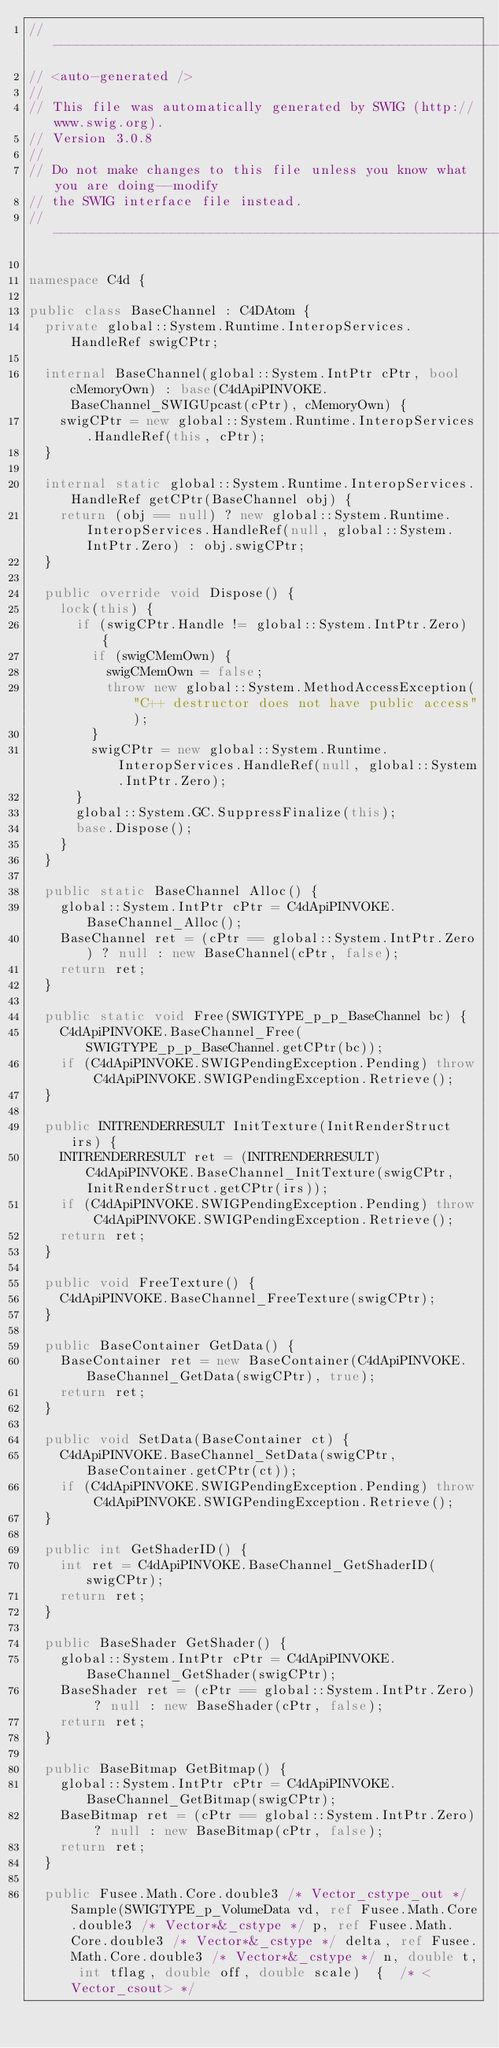<code> <loc_0><loc_0><loc_500><loc_500><_C#_>//------------------------------------------------------------------------------
// <auto-generated />
//
// This file was automatically generated by SWIG (http://www.swig.org).
// Version 3.0.8
//
// Do not make changes to this file unless you know what you are doing--modify
// the SWIG interface file instead.
//------------------------------------------------------------------------------

namespace C4d {

public class BaseChannel : C4DAtom {
  private global::System.Runtime.InteropServices.HandleRef swigCPtr;

  internal BaseChannel(global::System.IntPtr cPtr, bool cMemoryOwn) : base(C4dApiPINVOKE.BaseChannel_SWIGUpcast(cPtr), cMemoryOwn) {
    swigCPtr = new global::System.Runtime.InteropServices.HandleRef(this, cPtr);
  }

  internal static global::System.Runtime.InteropServices.HandleRef getCPtr(BaseChannel obj) {
    return (obj == null) ? new global::System.Runtime.InteropServices.HandleRef(null, global::System.IntPtr.Zero) : obj.swigCPtr;
  }

  public override void Dispose() {
    lock(this) {
      if (swigCPtr.Handle != global::System.IntPtr.Zero) {
        if (swigCMemOwn) {
          swigCMemOwn = false;
          throw new global::System.MethodAccessException("C++ destructor does not have public access");
        }
        swigCPtr = new global::System.Runtime.InteropServices.HandleRef(null, global::System.IntPtr.Zero);
      }
      global::System.GC.SuppressFinalize(this);
      base.Dispose();
    }
  }

  public static BaseChannel Alloc() {
    global::System.IntPtr cPtr = C4dApiPINVOKE.BaseChannel_Alloc();
    BaseChannel ret = (cPtr == global::System.IntPtr.Zero) ? null : new BaseChannel(cPtr, false);
    return ret;
  }

  public static void Free(SWIGTYPE_p_p_BaseChannel bc) {
    C4dApiPINVOKE.BaseChannel_Free(SWIGTYPE_p_p_BaseChannel.getCPtr(bc));
    if (C4dApiPINVOKE.SWIGPendingException.Pending) throw C4dApiPINVOKE.SWIGPendingException.Retrieve();
  }

  public INITRENDERRESULT InitTexture(InitRenderStruct irs) {
    INITRENDERRESULT ret = (INITRENDERRESULT)C4dApiPINVOKE.BaseChannel_InitTexture(swigCPtr, InitRenderStruct.getCPtr(irs));
    if (C4dApiPINVOKE.SWIGPendingException.Pending) throw C4dApiPINVOKE.SWIGPendingException.Retrieve();
    return ret;
  }

  public void FreeTexture() {
    C4dApiPINVOKE.BaseChannel_FreeTexture(swigCPtr);
  }

  public BaseContainer GetData() {
    BaseContainer ret = new BaseContainer(C4dApiPINVOKE.BaseChannel_GetData(swigCPtr), true);
    return ret;
  }

  public void SetData(BaseContainer ct) {
    C4dApiPINVOKE.BaseChannel_SetData(swigCPtr, BaseContainer.getCPtr(ct));
    if (C4dApiPINVOKE.SWIGPendingException.Pending) throw C4dApiPINVOKE.SWIGPendingException.Retrieve();
  }

  public int GetShaderID() {
    int ret = C4dApiPINVOKE.BaseChannel_GetShaderID(swigCPtr);
    return ret;
  }

  public BaseShader GetShader() {
    global::System.IntPtr cPtr = C4dApiPINVOKE.BaseChannel_GetShader(swigCPtr);
    BaseShader ret = (cPtr == global::System.IntPtr.Zero) ? null : new BaseShader(cPtr, false);
    return ret;
  }

  public BaseBitmap GetBitmap() {
    global::System.IntPtr cPtr = C4dApiPINVOKE.BaseChannel_GetBitmap(swigCPtr);
    BaseBitmap ret = (cPtr == global::System.IntPtr.Zero) ? null : new BaseBitmap(cPtr, false);
    return ret;
  }

  public Fusee.Math.Core.double3 /* Vector_cstype_out */ Sample(SWIGTYPE_p_VolumeData vd, ref Fusee.Math.Core.double3 /* Vector*&_cstype */ p, ref Fusee.Math.Core.double3 /* Vector*&_cstype */ delta, ref Fusee.Math.Core.double3 /* Vector*&_cstype */ n, double t, int tflag, double off, double scale)  {  /* <Vector_csout> */</code> 